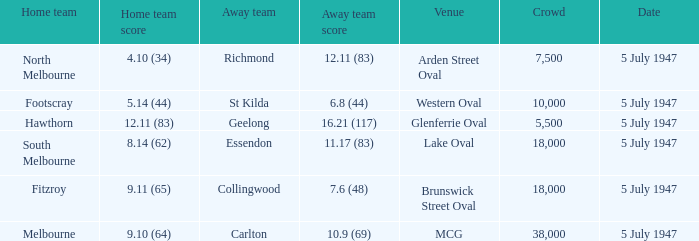8 (44)? Footscray. 